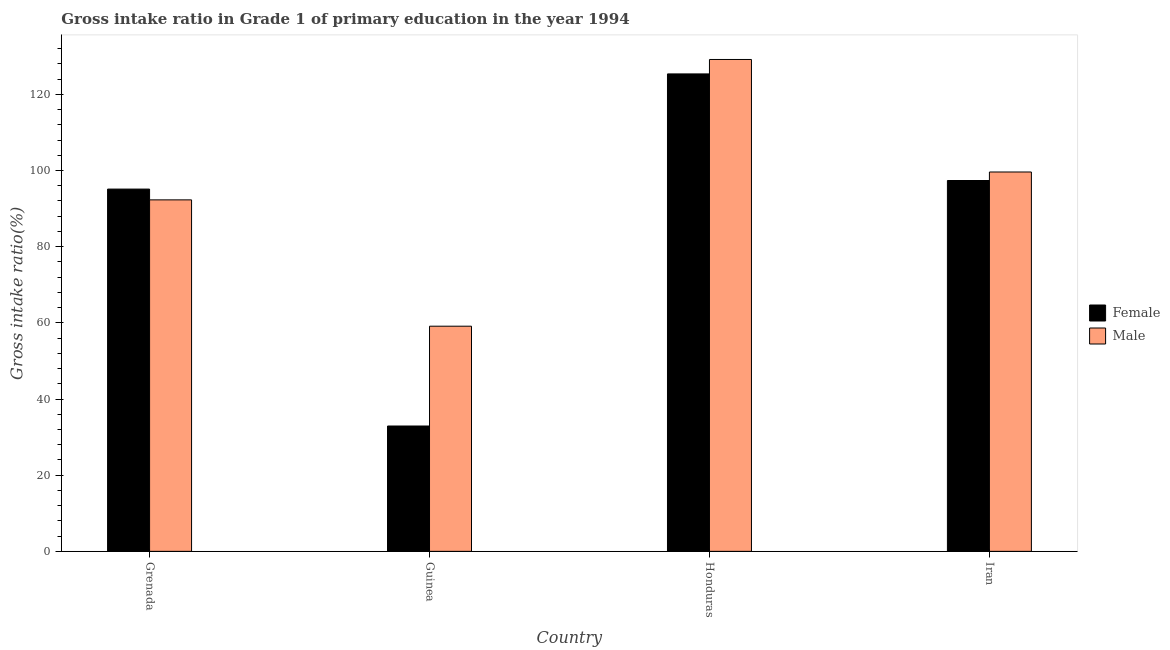Are the number of bars on each tick of the X-axis equal?
Offer a very short reply. Yes. How many bars are there on the 1st tick from the right?
Your answer should be very brief. 2. What is the label of the 2nd group of bars from the left?
Offer a very short reply. Guinea. In how many cases, is the number of bars for a given country not equal to the number of legend labels?
Ensure brevity in your answer.  0. What is the gross intake ratio(male) in Guinea?
Ensure brevity in your answer.  59.13. Across all countries, what is the maximum gross intake ratio(female)?
Make the answer very short. 125.37. Across all countries, what is the minimum gross intake ratio(male)?
Offer a very short reply. 59.13. In which country was the gross intake ratio(male) maximum?
Your answer should be very brief. Honduras. In which country was the gross intake ratio(male) minimum?
Your answer should be compact. Guinea. What is the total gross intake ratio(male) in the graph?
Provide a succinct answer. 380.2. What is the difference between the gross intake ratio(female) in Honduras and that in Iran?
Provide a short and direct response. 27.99. What is the difference between the gross intake ratio(female) in Iran and the gross intake ratio(male) in Honduras?
Your answer should be compact. -31.78. What is the average gross intake ratio(male) per country?
Offer a terse response. 95.05. What is the difference between the gross intake ratio(female) and gross intake ratio(male) in Guinea?
Provide a succinct answer. -26.21. In how many countries, is the gross intake ratio(female) greater than 88 %?
Offer a very short reply. 3. What is the ratio of the gross intake ratio(female) in Grenada to that in Guinea?
Provide a short and direct response. 2.89. Is the gross intake ratio(male) in Guinea less than that in Iran?
Your answer should be compact. Yes. What is the difference between the highest and the second highest gross intake ratio(female)?
Give a very brief answer. 27.99. What is the difference between the highest and the lowest gross intake ratio(female)?
Keep it short and to the point. 92.45. Is the sum of the gross intake ratio(female) in Honduras and Iran greater than the maximum gross intake ratio(male) across all countries?
Your answer should be very brief. Yes. What does the 2nd bar from the left in Honduras represents?
Make the answer very short. Male. What does the 1st bar from the right in Guinea represents?
Your answer should be compact. Male. Are all the bars in the graph horizontal?
Your answer should be very brief. No. How many countries are there in the graph?
Your answer should be compact. 4. Does the graph contain any zero values?
Provide a succinct answer. No. Does the graph contain grids?
Ensure brevity in your answer.  No. Where does the legend appear in the graph?
Provide a short and direct response. Center right. What is the title of the graph?
Provide a succinct answer. Gross intake ratio in Grade 1 of primary education in the year 1994. Does "Fertility rate" appear as one of the legend labels in the graph?
Your response must be concise. No. What is the label or title of the X-axis?
Offer a terse response. Country. What is the label or title of the Y-axis?
Provide a short and direct response. Gross intake ratio(%). What is the Gross intake ratio(%) in Female in Grenada?
Offer a terse response. 95.13. What is the Gross intake ratio(%) in Male in Grenada?
Your response must be concise. 92.3. What is the Gross intake ratio(%) in Female in Guinea?
Offer a terse response. 32.92. What is the Gross intake ratio(%) in Male in Guinea?
Offer a terse response. 59.13. What is the Gross intake ratio(%) of Female in Honduras?
Your response must be concise. 125.37. What is the Gross intake ratio(%) of Male in Honduras?
Your response must be concise. 129.16. What is the Gross intake ratio(%) of Female in Iran?
Make the answer very short. 97.38. What is the Gross intake ratio(%) in Male in Iran?
Make the answer very short. 99.61. Across all countries, what is the maximum Gross intake ratio(%) of Female?
Offer a terse response. 125.37. Across all countries, what is the maximum Gross intake ratio(%) of Male?
Provide a succinct answer. 129.16. Across all countries, what is the minimum Gross intake ratio(%) of Female?
Give a very brief answer. 32.92. Across all countries, what is the minimum Gross intake ratio(%) of Male?
Give a very brief answer. 59.13. What is the total Gross intake ratio(%) in Female in the graph?
Give a very brief answer. 350.79. What is the total Gross intake ratio(%) of Male in the graph?
Offer a terse response. 380.2. What is the difference between the Gross intake ratio(%) of Female in Grenada and that in Guinea?
Provide a succinct answer. 62.21. What is the difference between the Gross intake ratio(%) in Male in Grenada and that in Guinea?
Your answer should be very brief. 33.17. What is the difference between the Gross intake ratio(%) in Female in Grenada and that in Honduras?
Make the answer very short. -30.24. What is the difference between the Gross intake ratio(%) in Male in Grenada and that in Honduras?
Provide a short and direct response. -36.86. What is the difference between the Gross intake ratio(%) in Female in Grenada and that in Iran?
Provide a short and direct response. -2.25. What is the difference between the Gross intake ratio(%) of Male in Grenada and that in Iran?
Provide a succinct answer. -7.32. What is the difference between the Gross intake ratio(%) of Female in Guinea and that in Honduras?
Keep it short and to the point. -92.45. What is the difference between the Gross intake ratio(%) of Male in Guinea and that in Honduras?
Make the answer very short. -70.04. What is the difference between the Gross intake ratio(%) in Female in Guinea and that in Iran?
Keep it short and to the point. -64.46. What is the difference between the Gross intake ratio(%) in Male in Guinea and that in Iran?
Your answer should be compact. -40.49. What is the difference between the Gross intake ratio(%) in Female in Honduras and that in Iran?
Keep it short and to the point. 27.99. What is the difference between the Gross intake ratio(%) in Male in Honduras and that in Iran?
Provide a short and direct response. 29.55. What is the difference between the Gross intake ratio(%) of Female in Grenada and the Gross intake ratio(%) of Male in Guinea?
Your answer should be very brief. 36. What is the difference between the Gross intake ratio(%) in Female in Grenada and the Gross intake ratio(%) in Male in Honduras?
Offer a terse response. -34.03. What is the difference between the Gross intake ratio(%) in Female in Grenada and the Gross intake ratio(%) in Male in Iran?
Your answer should be compact. -4.49. What is the difference between the Gross intake ratio(%) of Female in Guinea and the Gross intake ratio(%) of Male in Honduras?
Give a very brief answer. -96.25. What is the difference between the Gross intake ratio(%) of Female in Guinea and the Gross intake ratio(%) of Male in Iran?
Provide a short and direct response. -66.7. What is the difference between the Gross intake ratio(%) in Female in Honduras and the Gross intake ratio(%) in Male in Iran?
Your answer should be compact. 25.76. What is the average Gross intake ratio(%) of Female per country?
Ensure brevity in your answer.  87.7. What is the average Gross intake ratio(%) in Male per country?
Provide a succinct answer. 95.05. What is the difference between the Gross intake ratio(%) in Female and Gross intake ratio(%) in Male in Grenada?
Offer a very short reply. 2.83. What is the difference between the Gross intake ratio(%) in Female and Gross intake ratio(%) in Male in Guinea?
Make the answer very short. -26.21. What is the difference between the Gross intake ratio(%) in Female and Gross intake ratio(%) in Male in Honduras?
Offer a terse response. -3.79. What is the difference between the Gross intake ratio(%) in Female and Gross intake ratio(%) in Male in Iran?
Give a very brief answer. -2.24. What is the ratio of the Gross intake ratio(%) in Female in Grenada to that in Guinea?
Make the answer very short. 2.89. What is the ratio of the Gross intake ratio(%) of Male in Grenada to that in Guinea?
Offer a terse response. 1.56. What is the ratio of the Gross intake ratio(%) in Female in Grenada to that in Honduras?
Your answer should be compact. 0.76. What is the ratio of the Gross intake ratio(%) of Male in Grenada to that in Honduras?
Your response must be concise. 0.71. What is the ratio of the Gross intake ratio(%) of Female in Grenada to that in Iran?
Offer a very short reply. 0.98. What is the ratio of the Gross intake ratio(%) in Male in Grenada to that in Iran?
Give a very brief answer. 0.93. What is the ratio of the Gross intake ratio(%) in Female in Guinea to that in Honduras?
Provide a short and direct response. 0.26. What is the ratio of the Gross intake ratio(%) of Male in Guinea to that in Honduras?
Give a very brief answer. 0.46. What is the ratio of the Gross intake ratio(%) in Female in Guinea to that in Iran?
Offer a terse response. 0.34. What is the ratio of the Gross intake ratio(%) in Male in Guinea to that in Iran?
Provide a short and direct response. 0.59. What is the ratio of the Gross intake ratio(%) of Female in Honduras to that in Iran?
Your answer should be compact. 1.29. What is the ratio of the Gross intake ratio(%) in Male in Honduras to that in Iran?
Provide a succinct answer. 1.3. What is the difference between the highest and the second highest Gross intake ratio(%) of Female?
Provide a succinct answer. 27.99. What is the difference between the highest and the second highest Gross intake ratio(%) of Male?
Your answer should be compact. 29.55. What is the difference between the highest and the lowest Gross intake ratio(%) in Female?
Keep it short and to the point. 92.45. What is the difference between the highest and the lowest Gross intake ratio(%) in Male?
Your response must be concise. 70.04. 